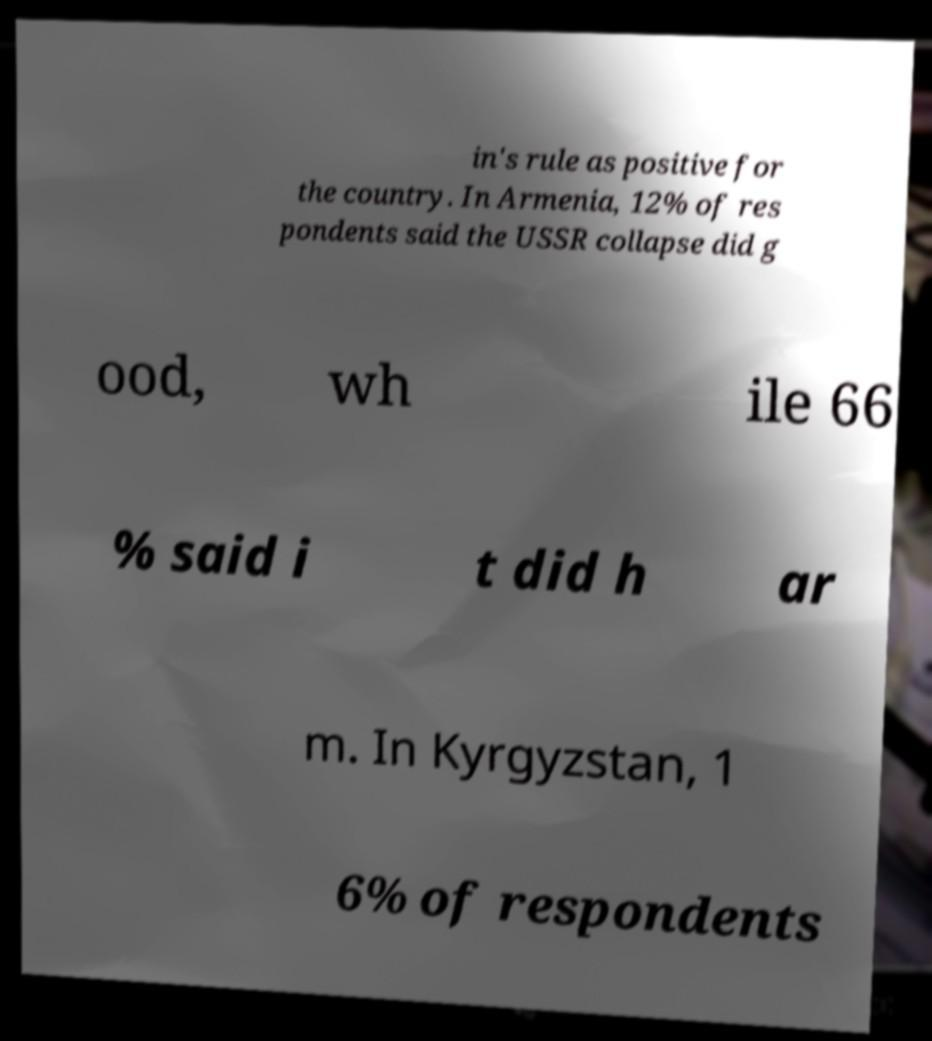I need the written content from this picture converted into text. Can you do that? in's rule as positive for the country. In Armenia, 12% of res pondents said the USSR collapse did g ood, wh ile 66 % said i t did h ar m. In Kyrgyzstan, 1 6% of respondents 